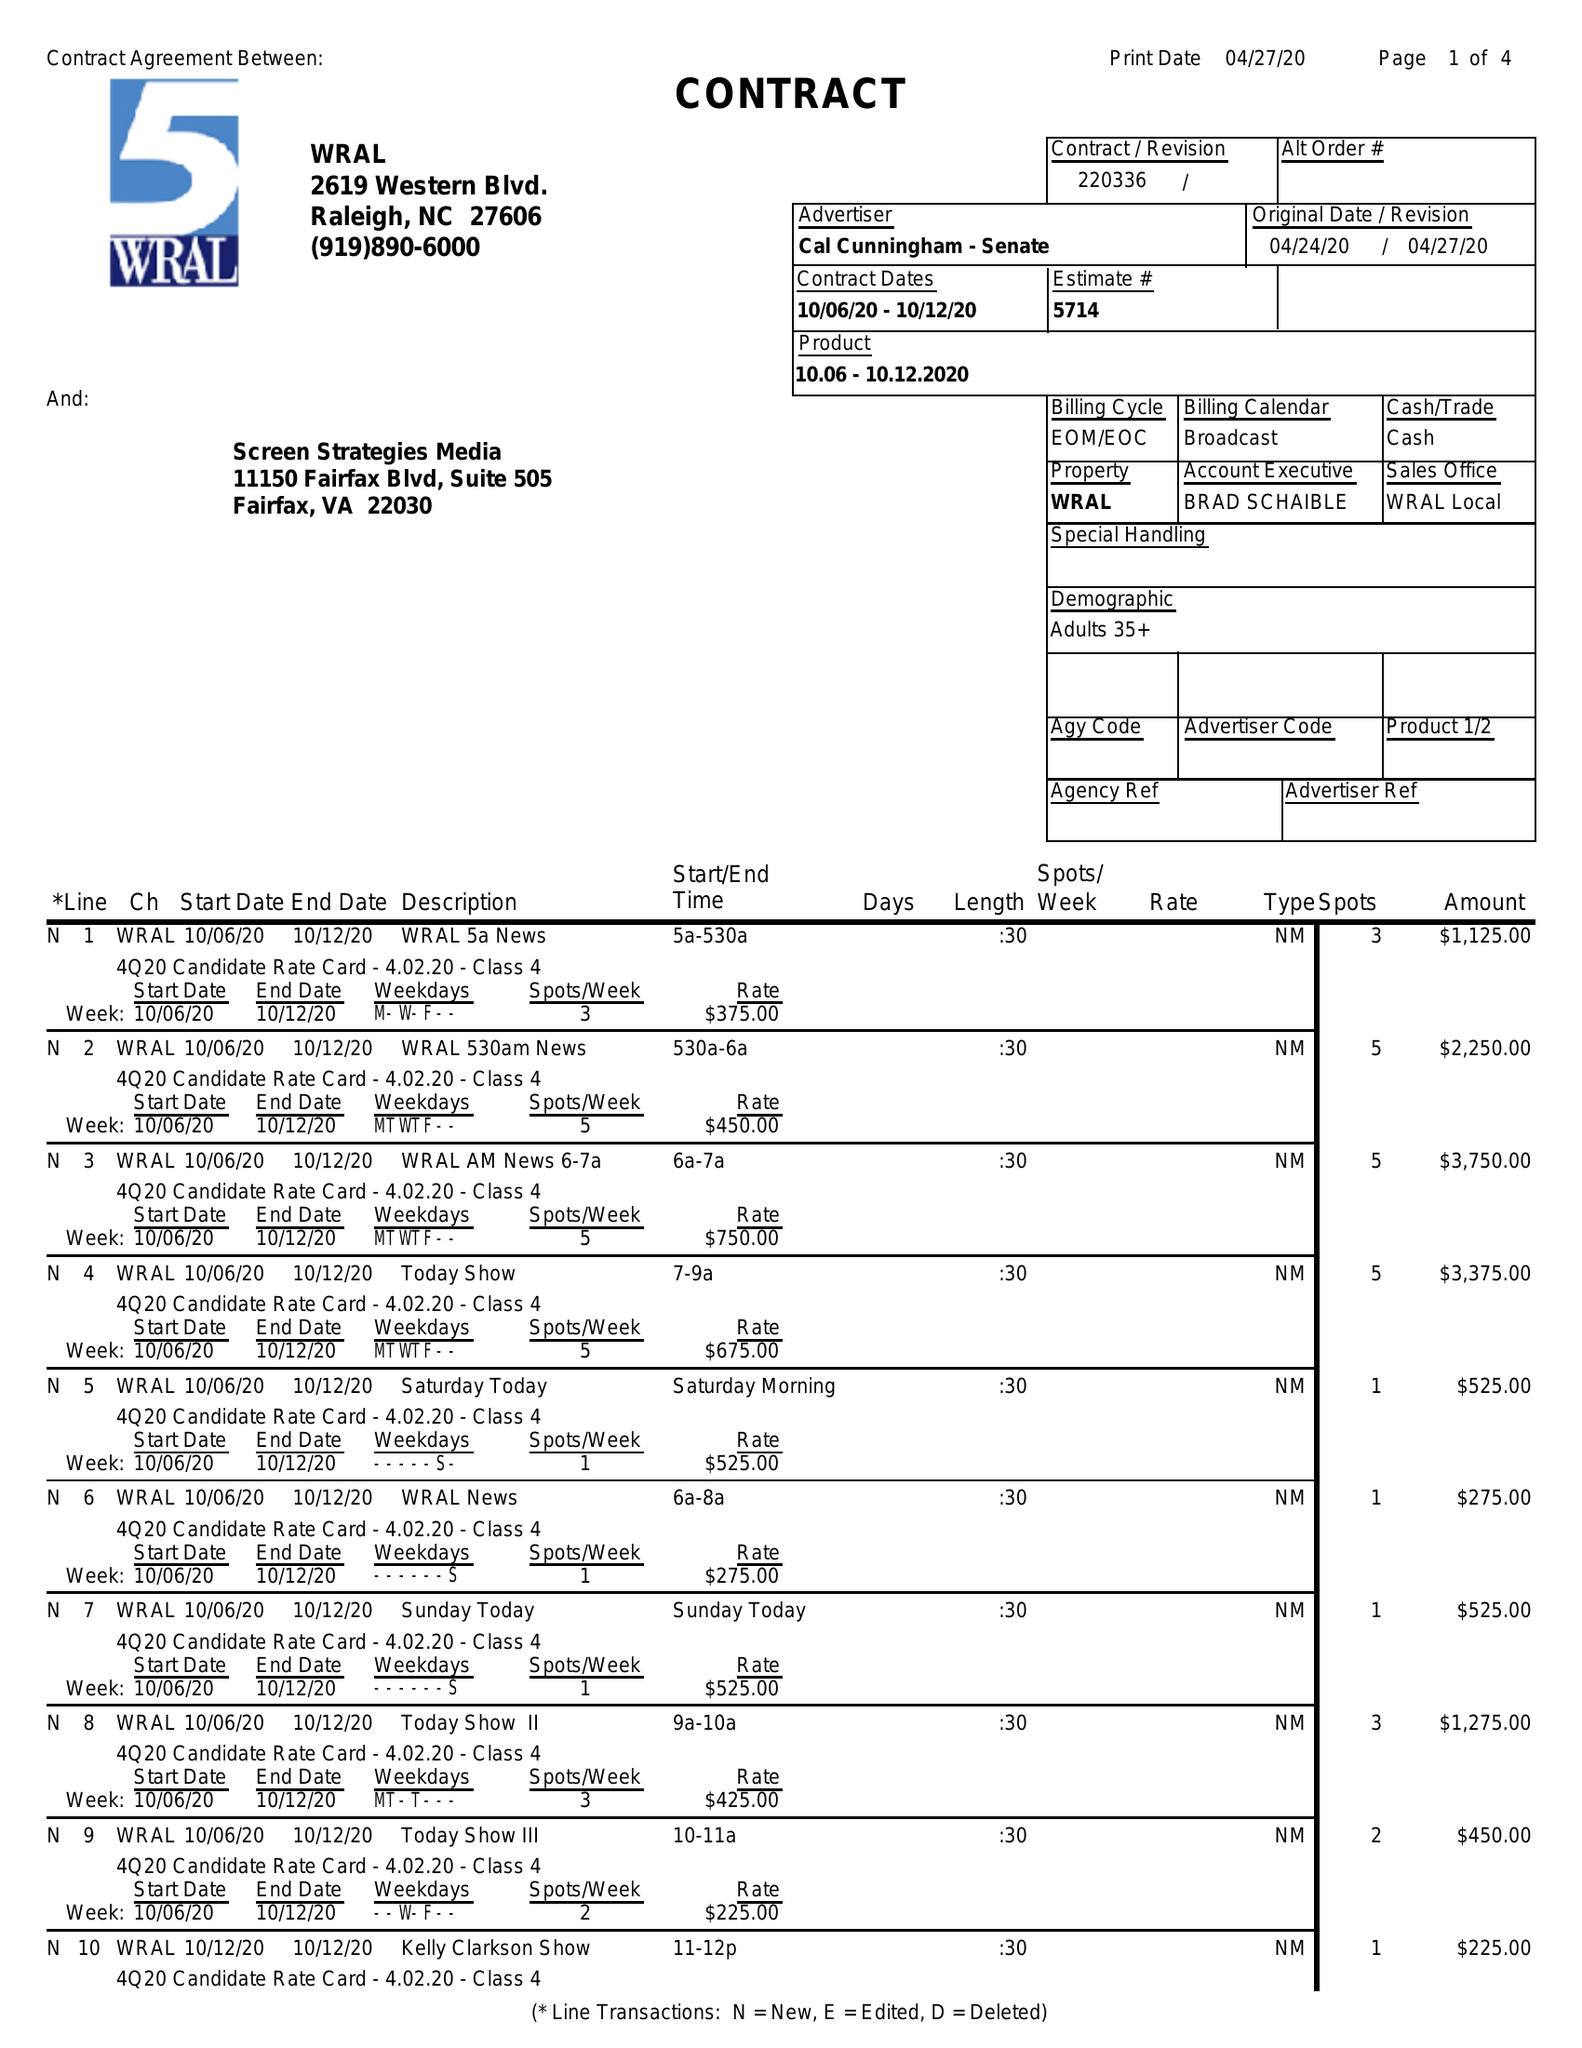What is the value for the flight_from?
Answer the question using a single word or phrase. 10/06/20 